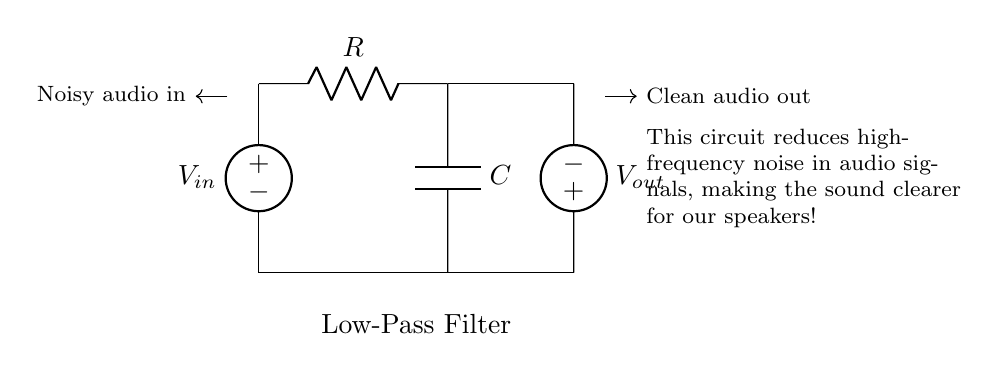What type of filter is this circuit? The circuit is labeled as a Low-Pass Filter, which is designed to allow low-frequency signals to pass while blocking high-frequency noise. This is indicated in the node below the circuit diagram.
Answer: Low-Pass Filter What are the components in this circuit? The circuit consists of a resistor (R) and a capacitor (C). Both components are depicted clearly in the circuit diagram, indicating their roles in filtering.
Answer: Resistor and Capacitor What is the purpose of this circuit? The purpose of the circuit is to reduce high-frequency noise in audio signals, making the resulting sound clearer. This is summarized in the description next to the circuit.
Answer: Reduce high-frequency noise What is the output voltage of this circuit labeled as? The output voltage is labeled as V out, which is the voltage provided to the speaker after the filtering process. This is seen at the far right of the circuit diagram.
Answer: V out How does this filter affect audio signals? The low-pass filter allows low-frequency audio signals to pass through while attenuating high-frequency noise, thus clarifying the sound. This concept is explained through the purpose of the circuit.
Answer: Clarifies sound What happens to high-frequency signals in this circuit? High-frequency signals are reduced or blocked by the low-pass filter, preventing them from reaching the output section of the circuit. This is the main function of the circuit as described.
Answer: Reduced or blocked 